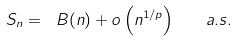<formula> <loc_0><loc_0><loc_500><loc_500>S _ { n } = \ B ( n ) + o \left ( n ^ { 1 / p } \right ) \quad a . s .</formula> 